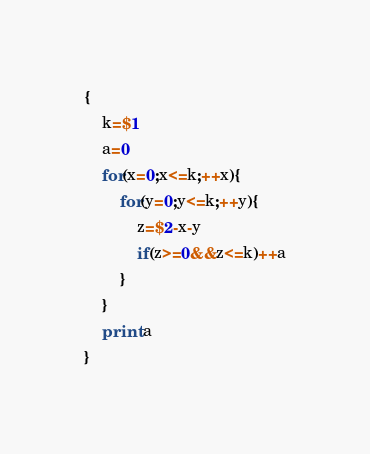Convert code to text. <code><loc_0><loc_0><loc_500><loc_500><_Awk_>{
    k=$1
    a=0
    for(x=0;x<=k;++x){
        for(y=0;y<=k;++y){
            z=$2-x-y
            if(z>=0&&z<=k)++a
        }
    }
    print a
}
</code> 